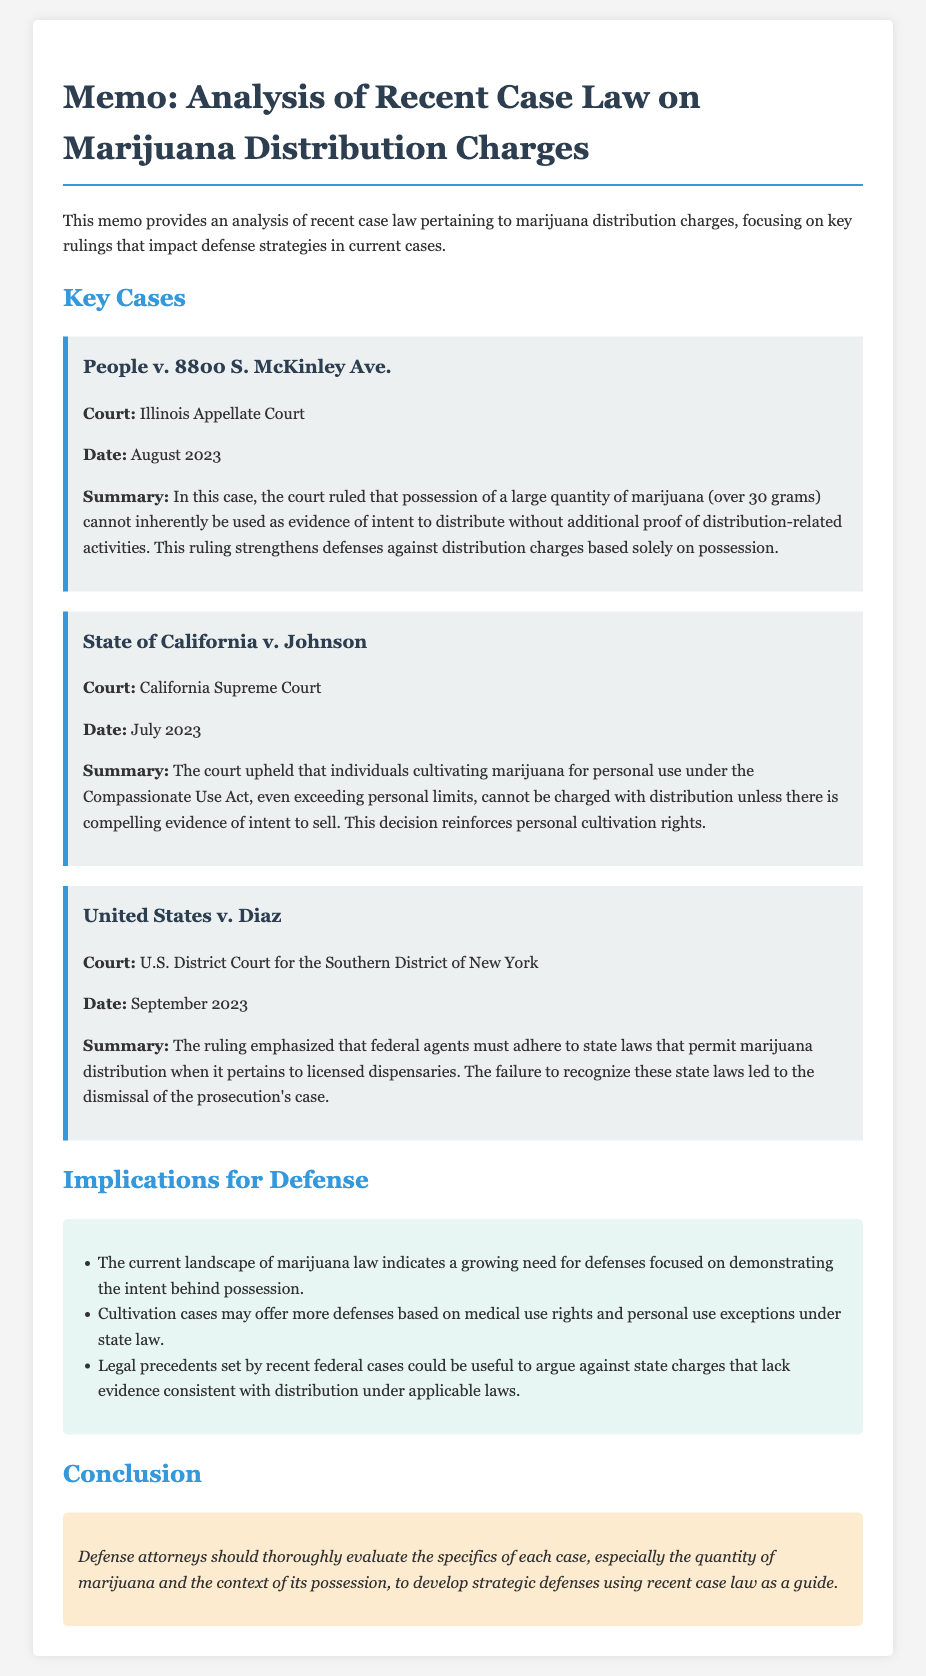What is the title of the memo? The title is the heading of the memo which summarizes its content, focusing on the analysis of marijuana distribution charges.
Answer: Memo: Analysis of Recent Case Law on Marijuana Distribution Charges When was the ruling in People v. 8800 S. McKinley Ave. issued? The date of the ruling is specified in the case summary, indicating when the court reached its decision.
Answer: August 2023 Which court ruled in State of California v. Johnson? The name of the court is detailed in the case summary and indicates the level of jurisdiction that made the ruling.
Answer: California Supreme Court What is a key implication for defense cases regarding marijuana distribution? This implication is derived from the legal trends discussed and indicates how defense strategies may evolve.
Answer: Intent behind possession What quantity of marijuana can indicate intent to distribute based on the memo? The document provides a specific quantity that the court considers without additional proof of distribution-related activities.
Answer: Over 30 grams What was emphasized in United States v. Diaz regarding federal agents? The summary indicates a key legal principle regarding the actions of federal agents in relation to state laws.
Answer: State laws When was the ruling in United States v. Diaz issued? The date is specified in the case summary, marking the timing of the ruling in this federal case.
Answer: September 2023 What does the conclusion suggest defense attorneys should evaluate? The conclusion offers specific advice on what factors should be considered when constructing a defense.
Answer: Specifics of each case Which act protects individuals cultivating marijuana for personal use in California? This information is specified in the case summary and identifies the legal framework that supports personal cultivation rights.
Answer: Compassionate Use Act 